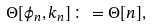Convert formula to latex. <formula><loc_0><loc_0><loc_500><loc_500>\Theta [ \phi _ { n } , k _ { n } ] \colon = \Theta [ n ] ,</formula> 